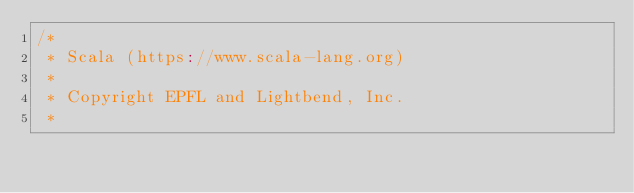Convert code to text. <code><loc_0><loc_0><loc_500><loc_500><_Scala_>/*
 * Scala (https://www.scala-lang.org)
 *
 * Copyright EPFL and Lightbend, Inc.
 *</code> 